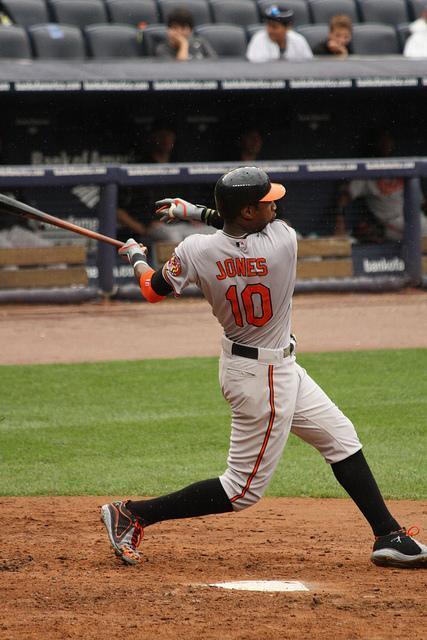How many people are in the picture?
Give a very brief answer. 2. 